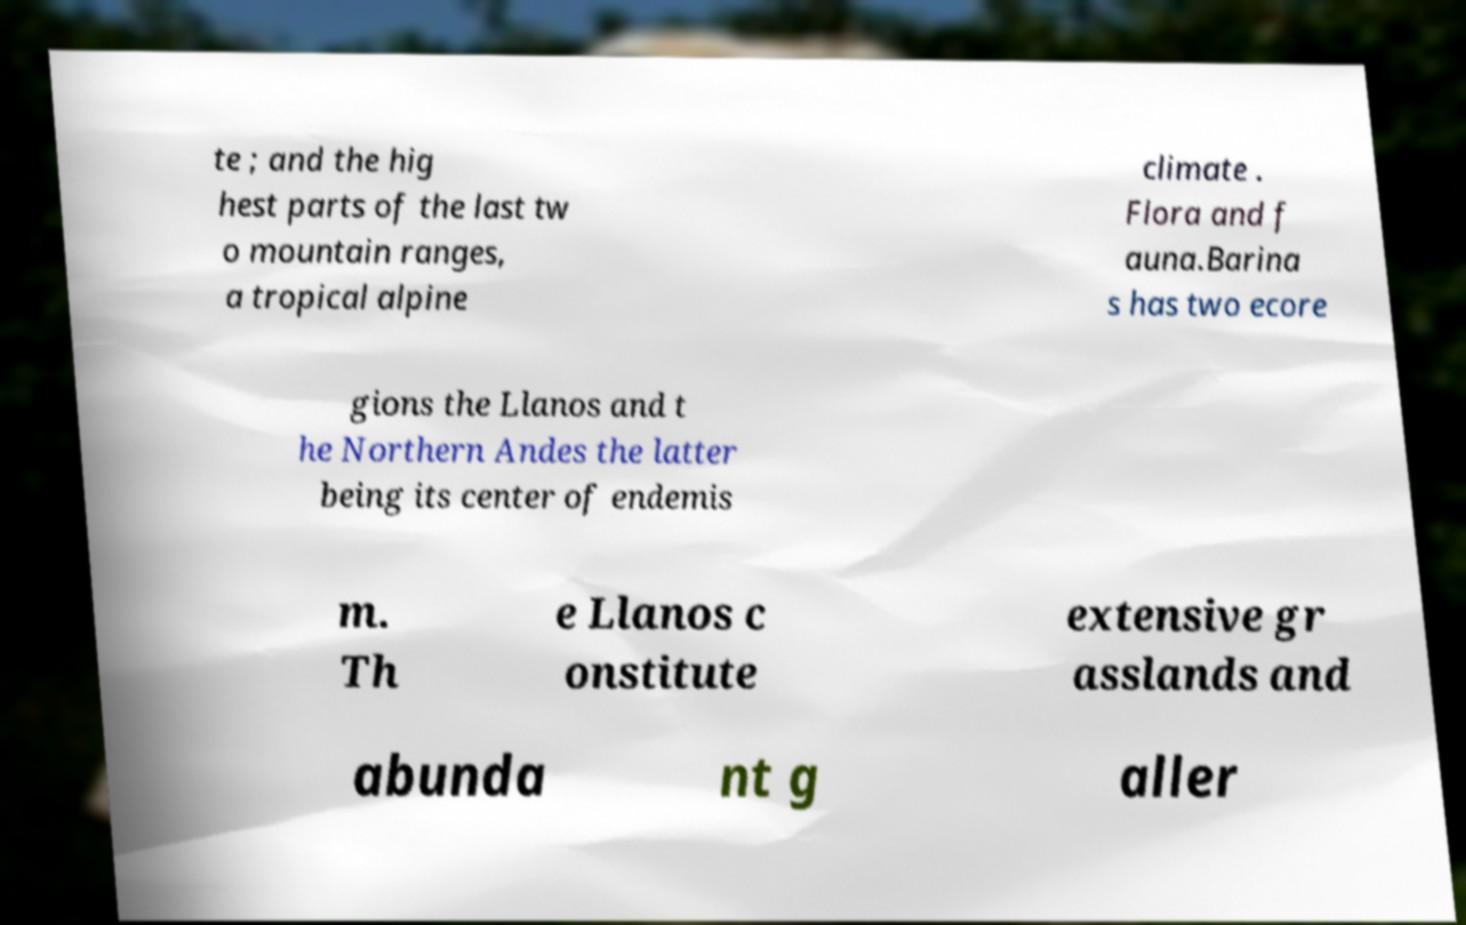Please identify and transcribe the text found in this image. te ; and the hig hest parts of the last tw o mountain ranges, a tropical alpine climate . Flora and f auna.Barina s has two ecore gions the Llanos and t he Northern Andes the latter being its center of endemis m. Th e Llanos c onstitute extensive gr asslands and abunda nt g aller 